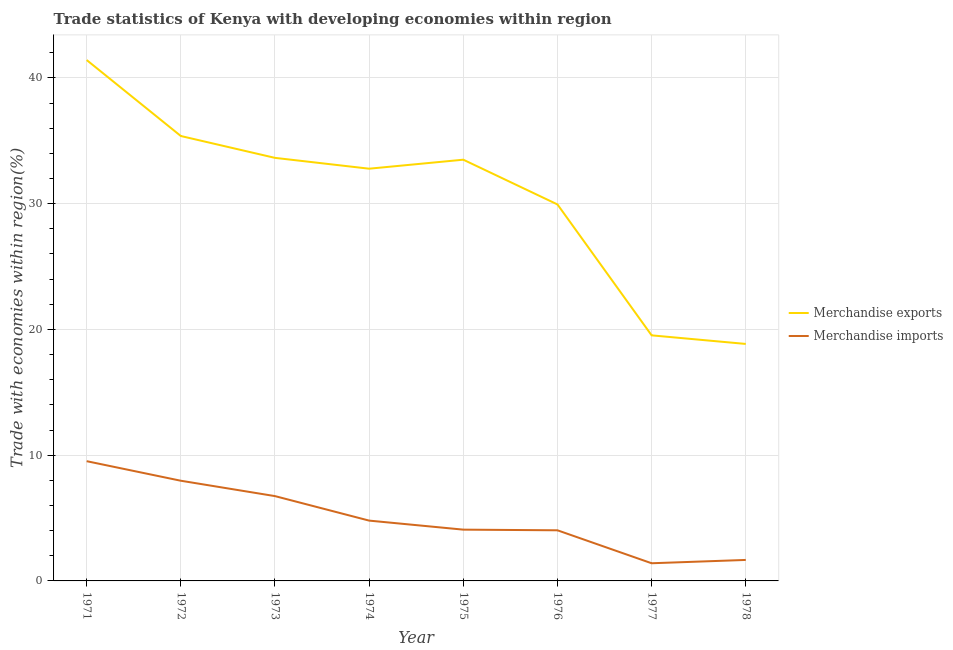What is the merchandise exports in 1977?
Offer a very short reply. 19.53. Across all years, what is the maximum merchandise imports?
Your answer should be very brief. 9.52. Across all years, what is the minimum merchandise exports?
Offer a very short reply. 18.84. In which year was the merchandise imports minimum?
Offer a very short reply. 1977. What is the total merchandise exports in the graph?
Your answer should be very brief. 245.01. What is the difference between the merchandise imports in 1971 and that in 1974?
Offer a very short reply. 4.73. What is the difference between the merchandise exports in 1974 and the merchandise imports in 1977?
Make the answer very short. 31.37. What is the average merchandise exports per year?
Provide a short and direct response. 30.63. In the year 1971, what is the difference between the merchandise exports and merchandise imports?
Provide a short and direct response. 31.9. In how many years, is the merchandise exports greater than 18 %?
Provide a short and direct response. 8. What is the ratio of the merchandise imports in 1974 to that in 1976?
Provide a succinct answer. 1.19. What is the difference between the highest and the second highest merchandise exports?
Your response must be concise. 6.04. What is the difference between the highest and the lowest merchandise exports?
Give a very brief answer. 22.57. Is the sum of the merchandise exports in 1972 and 1975 greater than the maximum merchandise imports across all years?
Keep it short and to the point. Yes. Does the merchandise exports monotonically increase over the years?
Your answer should be compact. No. How many lines are there?
Ensure brevity in your answer.  2. What is the difference between two consecutive major ticks on the Y-axis?
Your response must be concise. 10. What is the title of the graph?
Keep it short and to the point. Trade statistics of Kenya with developing economies within region. What is the label or title of the Y-axis?
Your answer should be compact. Trade with economies within region(%). What is the Trade with economies within region(%) in Merchandise exports in 1971?
Give a very brief answer. 41.42. What is the Trade with economies within region(%) in Merchandise imports in 1971?
Keep it short and to the point. 9.52. What is the Trade with economies within region(%) of Merchandise exports in 1972?
Keep it short and to the point. 35.38. What is the Trade with economies within region(%) of Merchandise imports in 1972?
Offer a terse response. 7.97. What is the Trade with economies within region(%) in Merchandise exports in 1973?
Ensure brevity in your answer.  33.64. What is the Trade with economies within region(%) in Merchandise imports in 1973?
Give a very brief answer. 6.74. What is the Trade with economies within region(%) in Merchandise exports in 1974?
Provide a succinct answer. 32.78. What is the Trade with economies within region(%) in Merchandise imports in 1974?
Your response must be concise. 4.8. What is the Trade with economies within region(%) of Merchandise exports in 1975?
Provide a succinct answer. 33.49. What is the Trade with economies within region(%) of Merchandise imports in 1975?
Provide a succinct answer. 4.08. What is the Trade with economies within region(%) in Merchandise exports in 1976?
Provide a succinct answer. 29.94. What is the Trade with economies within region(%) in Merchandise imports in 1976?
Your response must be concise. 4.03. What is the Trade with economies within region(%) of Merchandise exports in 1977?
Provide a succinct answer. 19.53. What is the Trade with economies within region(%) of Merchandise imports in 1977?
Your response must be concise. 1.4. What is the Trade with economies within region(%) of Merchandise exports in 1978?
Your response must be concise. 18.84. What is the Trade with economies within region(%) in Merchandise imports in 1978?
Your answer should be compact. 1.67. Across all years, what is the maximum Trade with economies within region(%) of Merchandise exports?
Offer a very short reply. 41.42. Across all years, what is the maximum Trade with economies within region(%) in Merchandise imports?
Give a very brief answer. 9.52. Across all years, what is the minimum Trade with economies within region(%) of Merchandise exports?
Provide a succinct answer. 18.84. Across all years, what is the minimum Trade with economies within region(%) of Merchandise imports?
Make the answer very short. 1.4. What is the total Trade with economies within region(%) of Merchandise exports in the graph?
Offer a very short reply. 245.01. What is the total Trade with economies within region(%) in Merchandise imports in the graph?
Give a very brief answer. 40.2. What is the difference between the Trade with economies within region(%) of Merchandise exports in 1971 and that in 1972?
Keep it short and to the point. 6.04. What is the difference between the Trade with economies within region(%) of Merchandise imports in 1971 and that in 1972?
Your answer should be compact. 1.56. What is the difference between the Trade with economies within region(%) in Merchandise exports in 1971 and that in 1973?
Give a very brief answer. 7.78. What is the difference between the Trade with economies within region(%) of Merchandise imports in 1971 and that in 1973?
Provide a short and direct response. 2.78. What is the difference between the Trade with economies within region(%) in Merchandise exports in 1971 and that in 1974?
Your answer should be very brief. 8.64. What is the difference between the Trade with economies within region(%) in Merchandise imports in 1971 and that in 1974?
Your answer should be compact. 4.73. What is the difference between the Trade with economies within region(%) of Merchandise exports in 1971 and that in 1975?
Your response must be concise. 7.92. What is the difference between the Trade with economies within region(%) in Merchandise imports in 1971 and that in 1975?
Offer a terse response. 5.44. What is the difference between the Trade with economies within region(%) of Merchandise exports in 1971 and that in 1976?
Ensure brevity in your answer.  11.48. What is the difference between the Trade with economies within region(%) of Merchandise imports in 1971 and that in 1976?
Provide a short and direct response. 5.5. What is the difference between the Trade with economies within region(%) of Merchandise exports in 1971 and that in 1977?
Offer a terse response. 21.89. What is the difference between the Trade with economies within region(%) of Merchandise imports in 1971 and that in 1977?
Make the answer very short. 8.12. What is the difference between the Trade with economies within region(%) in Merchandise exports in 1971 and that in 1978?
Make the answer very short. 22.57. What is the difference between the Trade with economies within region(%) in Merchandise imports in 1971 and that in 1978?
Provide a short and direct response. 7.85. What is the difference between the Trade with economies within region(%) of Merchandise exports in 1972 and that in 1973?
Offer a very short reply. 1.74. What is the difference between the Trade with economies within region(%) in Merchandise imports in 1972 and that in 1973?
Your answer should be compact. 1.22. What is the difference between the Trade with economies within region(%) in Merchandise exports in 1972 and that in 1974?
Offer a terse response. 2.6. What is the difference between the Trade with economies within region(%) of Merchandise imports in 1972 and that in 1974?
Keep it short and to the point. 3.17. What is the difference between the Trade with economies within region(%) in Merchandise exports in 1972 and that in 1975?
Make the answer very short. 1.88. What is the difference between the Trade with economies within region(%) in Merchandise imports in 1972 and that in 1975?
Your response must be concise. 3.89. What is the difference between the Trade with economies within region(%) in Merchandise exports in 1972 and that in 1976?
Provide a succinct answer. 5.44. What is the difference between the Trade with economies within region(%) in Merchandise imports in 1972 and that in 1976?
Your answer should be compact. 3.94. What is the difference between the Trade with economies within region(%) in Merchandise exports in 1972 and that in 1977?
Ensure brevity in your answer.  15.85. What is the difference between the Trade with economies within region(%) of Merchandise imports in 1972 and that in 1977?
Ensure brevity in your answer.  6.56. What is the difference between the Trade with economies within region(%) in Merchandise exports in 1972 and that in 1978?
Provide a short and direct response. 16.53. What is the difference between the Trade with economies within region(%) in Merchandise imports in 1972 and that in 1978?
Keep it short and to the point. 6.3. What is the difference between the Trade with economies within region(%) of Merchandise exports in 1973 and that in 1974?
Your answer should be compact. 0.86. What is the difference between the Trade with economies within region(%) of Merchandise imports in 1973 and that in 1974?
Ensure brevity in your answer.  1.95. What is the difference between the Trade with economies within region(%) in Merchandise exports in 1973 and that in 1975?
Offer a terse response. 0.15. What is the difference between the Trade with economies within region(%) in Merchandise imports in 1973 and that in 1975?
Make the answer very short. 2.67. What is the difference between the Trade with economies within region(%) in Merchandise exports in 1973 and that in 1976?
Offer a very short reply. 3.7. What is the difference between the Trade with economies within region(%) of Merchandise imports in 1973 and that in 1976?
Make the answer very short. 2.72. What is the difference between the Trade with economies within region(%) of Merchandise exports in 1973 and that in 1977?
Provide a succinct answer. 14.11. What is the difference between the Trade with economies within region(%) of Merchandise imports in 1973 and that in 1977?
Make the answer very short. 5.34. What is the difference between the Trade with economies within region(%) of Merchandise exports in 1973 and that in 1978?
Provide a short and direct response. 14.8. What is the difference between the Trade with economies within region(%) of Merchandise imports in 1973 and that in 1978?
Your response must be concise. 5.07. What is the difference between the Trade with economies within region(%) of Merchandise exports in 1974 and that in 1975?
Offer a very short reply. -0.72. What is the difference between the Trade with economies within region(%) in Merchandise imports in 1974 and that in 1975?
Give a very brief answer. 0.72. What is the difference between the Trade with economies within region(%) of Merchandise exports in 1974 and that in 1976?
Your answer should be compact. 2.84. What is the difference between the Trade with economies within region(%) of Merchandise imports in 1974 and that in 1976?
Give a very brief answer. 0.77. What is the difference between the Trade with economies within region(%) in Merchandise exports in 1974 and that in 1977?
Your response must be concise. 13.25. What is the difference between the Trade with economies within region(%) in Merchandise imports in 1974 and that in 1977?
Provide a short and direct response. 3.39. What is the difference between the Trade with economies within region(%) in Merchandise exports in 1974 and that in 1978?
Give a very brief answer. 13.93. What is the difference between the Trade with economies within region(%) of Merchandise imports in 1974 and that in 1978?
Offer a very short reply. 3.13. What is the difference between the Trade with economies within region(%) of Merchandise exports in 1975 and that in 1976?
Provide a short and direct response. 3.56. What is the difference between the Trade with economies within region(%) in Merchandise imports in 1975 and that in 1976?
Keep it short and to the point. 0.05. What is the difference between the Trade with economies within region(%) in Merchandise exports in 1975 and that in 1977?
Give a very brief answer. 13.97. What is the difference between the Trade with economies within region(%) of Merchandise imports in 1975 and that in 1977?
Your response must be concise. 2.67. What is the difference between the Trade with economies within region(%) of Merchandise exports in 1975 and that in 1978?
Offer a terse response. 14.65. What is the difference between the Trade with economies within region(%) of Merchandise imports in 1975 and that in 1978?
Keep it short and to the point. 2.41. What is the difference between the Trade with economies within region(%) in Merchandise exports in 1976 and that in 1977?
Provide a short and direct response. 10.41. What is the difference between the Trade with economies within region(%) of Merchandise imports in 1976 and that in 1977?
Your answer should be very brief. 2.62. What is the difference between the Trade with economies within region(%) of Merchandise exports in 1976 and that in 1978?
Your answer should be compact. 11.09. What is the difference between the Trade with economies within region(%) in Merchandise imports in 1976 and that in 1978?
Offer a very short reply. 2.36. What is the difference between the Trade with economies within region(%) in Merchandise exports in 1977 and that in 1978?
Your answer should be compact. 0.68. What is the difference between the Trade with economies within region(%) of Merchandise imports in 1977 and that in 1978?
Offer a very short reply. -0.26. What is the difference between the Trade with economies within region(%) in Merchandise exports in 1971 and the Trade with economies within region(%) in Merchandise imports in 1972?
Give a very brief answer. 33.45. What is the difference between the Trade with economies within region(%) in Merchandise exports in 1971 and the Trade with economies within region(%) in Merchandise imports in 1973?
Keep it short and to the point. 34.67. What is the difference between the Trade with economies within region(%) of Merchandise exports in 1971 and the Trade with economies within region(%) of Merchandise imports in 1974?
Offer a terse response. 36.62. What is the difference between the Trade with economies within region(%) in Merchandise exports in 1971 and the Trade with economies within region(%) in Merchandise imports in 1975?
Give a very brief answer. 37.34. What is the difference between the Trade with economies within region(%) in Merchandise exports in 1971 and the Trade with economies within region(%) in Merchandise imports in 1976?
Offer a very short reply. 37.39. What is the difference between the Trade with economies within region(%) of Merchandise exports in 1971 and the Trade with economies within region(%) of Merchandise imports in 1977?
Your answer should be very brief. 40.01. What is the difference between the Trade with economies within region(%) in Merchandise exports in 1971 and the Trade with economies within region(%) in Merchandise imports in 1978?
Ensure brevity in your answer.  39.75. What is the difference between the Trade with economies within region(%) of Merchandise exports in 1972 and the Trade with economies within region(%) of Merchandise imports in 1973?
Your answer should be compact. 28.63. What is the difference between the Trade with economies within region(%) in Merchandise exports in 1972 and the Trade with economies within region(%) in Merchandise imports in 1974?
Offer a very short reply. 30.58. What is the difference between the Trade with economies within region(%) of Merchandise exports in 1972 and the Trade with economies within region(%) of Merchandise imports in 1975?
Give a very brief answer. 31.3. What is the difference between the Trade with economies within region(%) of Merchandise exports in 1972 and the Trade with economies within region(%) of Merchandise imports in 1976?
Offer a very short reply. 31.35. What is the difference between the Trade with economies within region(%) in Merchandise exports in 1972 and the Trade with economies within region(%) in Merchandise imports in 1977?
Provide a succinct answer. 33.97. What is the difference between the Trade with economies within region(%) of Merchandise exports in 1972 and the Trade with economies within region(%) of Merchandise imports in 1978?
Your answer should be compact. 33.71. What is the difference between the Trade with economies within region(%) in Merchandise exports in 1973 and the Trade with economies within region(%) in Merchandise imports in 1974?
Your answer should be very brief. 28.84. What is the difference between the Trade with economies within region(%) of Merchandise exports in 1973 and the Trade with economies within region(%) of Merchandise imports in 1975?
Provide a short and direct response. 29.56. What is the difference between the Trade with economies within region(%) of Merchandise exports in 1973 and the Trade with economies within region(%) of Merchandise imports in 1976?
Your answer should be very brief. 29.61. What is the difference between the Trade with economies within region(%) of Merchandise exports in 1973 and the Trade with economies within region(%) of Merchandise imports in 1977?
Ensure brevity in your answer.  32.23. What is the difference between the Trade with economies within region(%) in Merchandise exports in 1973 and the Trade with economies within region(%) in Merchandise imports in 1978?
Your answer should be very brief. 31.97. What is the difference between the Trade with economies within region(%) in Merchandise exports in 1974 and the Trade with economies within region(%) in Merchandise imports in 1975?
Give a very brief answer. 28.7. What is the difference between the Trade with economies within region(%) in Merchandise exports in 1974 and the Trade with economies within region(%) in Merchandise imports in 1976?
Your answer should be very brief. 28.75. What is the difference between the Trade with economies within region(%) of Merchandise exports in 1974 and the Trade with economies within region(%) of Merchandise imports in 1977?
Offer a terse response. 31.37. What is the difference between the Trade with economies within region(%) in Merchandise exports in 1974 and the Trade with economies within region(%) in Merchandise imports in 1978?
Offer a terse response. 31.11. What is the difference between the Trade with economies within region(%) in Merchandise exports in 1975 and the Trade with economies within region(%) in Merchandise imports in 1976?
Give a very brief answer. 29.47. What is the difference between the Trade with economies within region(%) in Merchandise exports in 1975 and the Trade with economies within region(%) in Merchandise imports in 1977?
Ensure brevity in your answer.  32.09. What is the difference between the Trade with economies within region(%) of Merchandise exports in 1975 and the Trade with economies within region(%) of Merchandise imports in 1978?
Your answer should be compact. 31.82. What is the difference between the Trade with economies within region(%) of Merchandise exports in 1976 and the Trade with economies within region(%) of Merchandise imports in 1977?
Offer a very short reply. 28.53. What is the difference between the Trade with economies within region(%) in Merchandise exports in 1976 and the Trade with economies within region(%) in Merchandise imports in 1978?
Offer a very short reply. 28.27. What is the difference between the Trade with economies within region(%) of Merchandise exports in 1977 and the Trade with economies within region(%) of Merchandise imports in 1978?
Your answer should be very brief. 17.86. What is the average Trade with economies within region(%) of Merchandise exports per year?
Offer a very short reply. 30.63. What is the average Trade with economies within region(%) of Merchandise imports per year?
Offer a terse response. 5.03. In the year 1971, what is the difference between the Trade with economies within region(%) of Merchandise exports and Trade with economies within region(%) of Merchandise imports?
Give a very brief answer. 31.9. In the year 1972, what is the difference between the Trade with economies within region(%) in Merchandise exports and Trade with economies within region(%) in Merchandise imports?
Offer a terse response. 27.41. In the year 1973, what is the difference between the Trade with economies within region(%) of Merchandise exports and Trade with economies within region(%) of Merchandise imports?
Offer a terse response. 26.9. In the year 1974, what is the difference between the Trade with economies within region(%) of Merchandise exports and Trade with economies within region(%) of Merchandise imports?
Make the answer very short. 27.98. In the year 1975, what is the difference between the Trade with economies within region(%) of Merchandise exports and Trade with economies within region(%) of Merchandise imports?
Make the answer very short. 29.42. In the year 1976, what is the difference between the Trade with economies within region(%) of Merchandise exports and Trade with economies within region(%) of Merchandise imports?
Your answer should be compact. 25.91. In the year 1977, what is the difference between the Trade with economies within region(%) of Merchandise exports and Trade with economies within region(%) of Merchandise imports?
Keep it short and to the point. 18.12. In the year 1978, what is the difference between the Trade with economies within region(%) of Merchandise exports and Trade with economies within region(%) of Merchandise imports?
Offer a very short reply. 17.17. What is the ratio of the Trade with economies within region(%) of Merchandise exports in 1971 to that in 1972?
Keep it short and to the point. 1.17. What is the ratio of the Trade with economies within region(%) in Merchandise imports in 1971 to that in 1972?
Your response must be concise. 1.2. What is the ratio of the Trade with economies within region(%) in Merchandise exports in 1971 to that in 1973?
Provide a succinct answer. 1.23. What is the ratio of the Trade with economies within region(%) of Merchandise imports in 1971 to that in 1973?
Your answer should be very brief. 1.41. What is the ratio of the Trade with economies within region(%) in Merchandise exports in 1971 to that in 1974?
Provide a succinct answer. 1.26. What is the ratio of the Trade with economies within region(%) of Merchandise imports in 1971 to that in 1974?
Your answer should be very brief. 1.99. What is the ratio of the Trade with economies within region(%) of Merchandise exports in 1971 to that in 1975?
Offer a very short reply. 1.24. What is the ratio of the Trade with economies within region(%) of Merchandise imports in 1971 to that in 1975?
Offer a terse response. 2.34. What is the ratio of the Trade with economies within region(%) in Merchandise exports in 1971 to that in 1976?
Provide a short and direct response. 1.38. What is the ratio of the Trade with economies within region(%) of Merchandise imports in 1971 to that in 1976?
Keep it short and to the point. 2.37. What is the ratio of the Trade with economies within region(%) in Merchandise exports in 1971 to that in 1977?
Ensure brevity in your answer.  2.12. What is the ratio of the Trade with economies within region(%) of Merchandise imports in 1971 to that in 1977?
Make the answer very short. 6.78. What is the ratio of the Trade with economies within region(%) in Merchandise exports in 1971 to that in 1978?
Offer a terse response. 2.2. What is the ratio of the Trade with economies within region(%) of Merchandise imports in 1971 to that in 1978?
Provide a succinct answer. 5.7. What is the ratio of the Trade with economies within region(%) of Merchandise exports in 1972 to that in 1973?
Offer a very short reply. 1.05. What is the ratio of the Trade with economies within region(%) of Merchandise imports in 1972 to that in 1973?
Make the answer very short. 1.18. What is the ratio of the Trade with economies within region(%) in Merchandise exports in 1972 to that in 1974?
Offer a very short reply. 1.08. What is the ratio of the Trade with economies within region(%) in Merchandise imports in 1972 to that in 1974?
Make the answer very short. 1.66. What is the ratio of the Trade with economies within region(%) of Merchandise exports in 1972 to that in 1975?
Provide a short and direct response. 1.06. What is the ratio of the Trade with economies within region(%) of Merchandise imports in 1972 to that in 1975?
Your answer should be compact. 1.95. What is the ratio of the Trade with economies within region(%) in Merchandise exports in 1972 to that in 1976?
Ensure brevity in your answer.  1.18. What is the ratio of the Trade with economies within region(%) of Merchandise imports in 1972 to that in 1976?
Keep it short and to the point. 1.98. What is the ratio of the Trade with economies within region(%) of Merchandise exports in 1972 to that in 1977?
Your response must be concise. 1.81. What is the ratio of the Trade with economies within region(%) of Merchandise imports in 1972 to that in 1977?
Give a very brief answer. 5.67. What is the ratio of the Trade with economies within region(%) in Merchandise exports in 1972 to that in 1978?
Make the answer very short. 1.88. What is the ratio of the Trade with economies within region(%) of Merchandise imports in 1972 to that in 1978?
Offer a very short reply. 4.77. What is the ratio of the Trade with economies within region(%) of Merchandise exports in 1973 to that in 1974?
Your answer should be very brief. 1.03. What is the ratio of the Trade with economies within region(%) of Merchandise imports in 1973 to that in 1974?
Offer a terse response. 1.41. What is the ratio of the Trade with economies within region(%) in Merchandise exports in 1973 to that in 1975?
Your answer should be very brief. 1. What is the ratio of the Trade with economies within region(%) in Merchandise imports in 1973 to that in 1975?
Ensure brevity in your answer.  1.65. What is the ratio of the Trade with economies within region(%) of Merchandise exports in 1973 to that in 1976?
Give a very brief answer. 1.12. What is the ratio of the Trade with economies within region(%) in Merchandise imports in 1973 to that in 1976?
Give a very brief answer. 1.68. What is the ratio of the Trade with economies within region(%) of Merchandise exports in 1973 to that in 1977?
Your answer should be very brief. 1.72. What is the ratio of the Trade with economies within region(%) in Merchandise imports in 1973 to that in 1977?
Offer a very short reply. 4.8. What is the ratio of the Trade with economies within region(%) of Merchandise exports in 1973 to that in 1978?
Your answer should be very brief. 1.79. What is the ratio of the Trade with economies within region(%) in Merchandise imports in 1973 to that in 1978?
Your answer should be compact. 4.04. What is the ratio of the Trade with economies within region(%) of Merchandise exports in 1974 to that in 1975?
Keep it short and to the point. 0.98. What is the ratio of the Trade with economies within region(%) in Merchandise imports in 1974 to that in 1975?
Your answer should be compact. 1.18. What is the ratio of the Trade with economies within region(%) in Merchandise exports in 1974 to that in 1976?
Provide a succinct answer. 1.09. What is the ratio of the Trade with economies within region(%) of Merchandise imports in 1974 to that in 1976?
Give a very brief answer. 1.19. What is the ratio of the Trade with economies within region(%) in Merchandise exports in 1974 to that in 1977?
Provide a succinct answer. 1.68. What is the ratio of the Trade with economies within region(%) of Merchandise imports in 1974 to that in 1977?
Provide a succinct answer. 3.41. What is the ratio of the Trade with economies within region(%) in Merchandise exports in 1974 to that in 1978?
Offer a very short reply. 1.74. What is the ratio of the Trade with economies within region(%) in Merchandise imports in 1974 to that in 1978?
Keep it short and to the point. 2.87. What is the ratio of the Trade with economies within region(%) of Merchandise exports in 1975 to that in 1976?
Provide a succinct answer. 1.12. What is the ratio of the Trade with economies within region(%) of Merchandise imports in 1975 to that in 1976?
Offer a terse response. 1.01. What is the ratio of the Trade with economies within region(%) of Merchandise exports in 1975 to that in 1977?
Your answer should be very brief. 1.72. What is the ratio of the Trade with economies within region(%) in Merchandise imports in 1975 to that in 1977?
Your answer should be compact. 2.9. What is the ratio of the Trade with economies within region(%) of Merchandise exports in 1975 to that in 1978?
Your answer should be compact. 1.78. What is the ratio of the Trade with economies within region(%) of Merchandise imports in 1975 to that in 1978?
Offer a very short reply. 2.44. What is the ratio of the Trade with economies within region(%) of Merchandise exports in 1976 to that in 1977?
Your response must be concise. 1.53. What is the ratio of the Trade with economies within region(%) of Merchandise imports in 1976 to that in 1977?
Provide a short and direct response. 2.87. What is the ratio of the Trade with economies within region(%) in Merchandise exports in 1976 to that in 1978?
Your answer should be compact. 1.59. What is the ratio of the Trade with economies within region(%) of Merchandise imports in 1976 to that in 1978?
Offer a terse response. 2.41. What is the ratio of the Trade with economies within region(%) of Merchandise exports in 1977 to that in 1978?
Give a very brief answer. 1.04. What is the ratio of the Trade with economies within region(%) of Merchandise imports in 1977 to that in 1978?
Make the answer very short. 0.84. What is the difference between the highest and the second highest Trade with economies within region(%) of Merchandise exports?
Offer a terse response. 6.04. What is the difference between the highest and the second highest Trade with economies within region(%) of Merchandise imports?
Give a very brief answer. 1.56. What is the difference between the highest and the lowest Trade with economies within region(%) of Merchandise exports?
Provide a short and direct response. 22.57. What is the difference between the highest and the lowest Trade with economies within region(%) in Merchandise imports?
Offer a terse response. 8.12. 